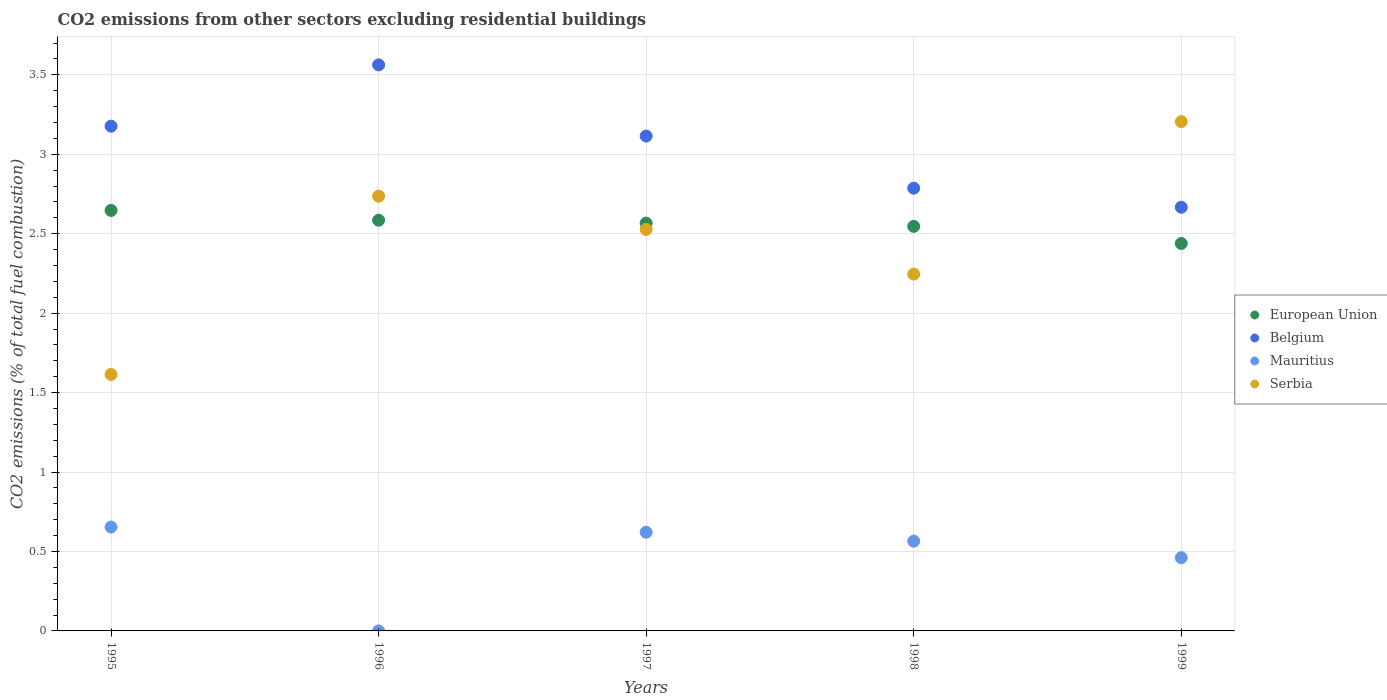How many different coloured dotlines are there?
Ensure brevity in your answer.  4. Is the number of dotlines equal to the number of legend labels?
Offer a very short reply. Yes. What is the total CO2 emitted in Belgium in 1998?
Make the answer very short. 2.79. Across all years, what is the maximum total CO2 emitted in Belgium?
Offer a very short reply. 3.56. Across all years, what is the minimum total CO2 emitted in Serbia?
Give a very brief answer. 1.61. What is the total total CO2 emitted in Mauritius in the graph?
Your answer should be very brief. 2.3. What is the difference between the total CO2 emitted in Serbia in 1997 and that in 1999?
Your answer should be very brief. -0.68. What is the difference between the total CO2 emitted in Belgium in 1995 and the total CO2 emitted in Serbia in 1999?
Provide a short and direct response. -0.03. What is the average total CO2 emitted in Mauritius per year?
Ensure brevity in your answer.  0.46. In the year 1996, what is the difference between the total CO2 emitted in Mauritius and total CO2 emitted in Belgium?
Your answer should be very brief. -3.56. In how many years, is the total CO2 emitted in Belgium greater than 0.6?
Provide a succinct answer. 5. What is the ratio of the total CO2 emitted in Serbia in 1996 to that in 1997?
Ensure brevity in your answer.  1.08. Is the difference between the total CO2 emitted in Mauritius in 1996 and 1999 greater than the difference between the total CO2 emitted in Belgium in 1996 and 1999?
Ensure brevity in your answer.  No. What is the difference between the highest and the second highest total CO2 emitted in Serbia?
Ensure brevity in your answer.  0.47. What is the difference between the highest and the lowest total CO2 emitted in Serbia?
Give a very brief answer. 1.59. In how many years, is the total CO2 emitted in Belgium greater than the average total CO2 emitted in Belgium taken over all years?
Provide a succinct answer. 3. Is it the case that in every year, the sum of the total CO2 emitted in Serbia and total CO2 emitted in Belgium  is greater than the total CO2 emitted in European Union?
Your answer should be compact. Yes. Does the total CO2 emitted in Belgium monotonically increase over the years?
Your answer should be compact. No. How many years are there in the graph?
Offer a very short reply. 5. Does the graph contain any zero values?
Ensure brevity in your answer.  No. Does the graph contain grids?
Keep it short and to the point. Yes. How many legend labels are there?
Keep it short and to the point. 4. How are the legend labels stacked?
Offer a terse response. Vertical. What is the title of the graph?
Ensure brevity in your answer.  CO2 emissions from other sectors excluding residential buildings. What is the label or title of the Y-axis?
Offer a very short reply. CO2 emissions (% of total fuel combustion). What is the CO2 emissions (% of total fuel combustion) in European Union in 1995?
Your response must be concise. 2.65. What is the CO2 emissions (% of total fuel combustion) in Belgium in 1995?
Ensure brevity in your answer.  3.18. What is the CO2 emissions (% of total fuel combustion) in Mauritius in 1995?
Your answer should be very brief. 0.65. What is the CO2 emissions (% of total fuel combustion) of Serbia in 1995?
Offer a very short reply. 1.61. What is the CO2 emissions (% of total fuel combustion) of European Union in 1996?
Your answer should be very brief. 2.58. What is the CO2 emissions (% of total fuel combustion) in Belgium in 1996?
Offer a terse response. 3.56. What is the CO2 emissions (% of total fuel combustion) in Mauritius in 1996?
Offer a terse response. 5.421010862427518e-16. What is the CO2 emissions (% of total fuel combustion) in Serbia in 1996?
Give a very brief answer. 2.74. What is the CO2 emissions (% of total fuel combustion) of European Union in 1997?
Make the answer very short. 2.57. What is the CO2 emissions (% of total fuel combustion) of Belgium in 1997?
Give a very brief answer. 3.11. What is the CO2 emissions (% of total fuel combustion) in Mauritius in 1997?
Your answer should be compact. 0.62. What is the CO2 emissions (% of total fuel combustion) of Serbia in 1997?
Your answer should be compact. 2.53. What is the CO2 emissions (% of total fuel combustion) of European Union in 1998?
Offer a terse response. 2.55. What is the CO2 emissions (% of total fuel combustion) in Belgium in 1998?
Your response must be concise. 2.79. What is the CO2 emissions (% of total fuel combustion) in Mauritius in 1998?
Give a very brief answer. 0.56. What is the CO2 emissions (% of total fuel combustion) of Serbia in 1998?
Your answer should be compact. 2.25. What is the CO2 emissions (% of total fuel combustion) of European Union in 1999?
Your response must be concise. 2.44. What is the CO2 emissions (% of total fuel combustion) in Belgium in 1999?
Keep it short and to the point. 2.67. What is the CO2 emissions (% of total fuel combustion) of Mauritius in 1999?
Keep it short and to the point. 0.46. What is the CO2 emissions (% of total fuel combustion) in Serbia in 1999?
Provide a succinct answer. 3.21. Across all years, what is the maximum CO2 emissions (% of total fuel combustion) of European Union?
Provide a succinct answer. 2.65. Across all years, what is the maximum CO2 emissions (% of total fuel combustion) of Belgium?
Give a very brief answer. 3.56. Across all years, what is the maximum CO2 emissions (% of total fuel combustion) in Mauritius?
Your response must be concise. 0.65. Across all years, what is the maximum CO2 emissions (% of total fuel combustion) in Serbia?
Keep it short and to the point. 3.21. Across all years, what is the minimum CO2 emissions (% of total fuel combustion) of European Union?
Your response must be concise. 2.44. Across all years, what is the minimum CO2 emissions (% of total fuel combustion) in Belgium?
Provide a succinct answer. 2.67. Across all years, what is the minimum CO2 emissions (% of total fuel combustion) of Mauritius?
Keep it short and to the point. 5.421010862427518e-16. Across all years, what is the minimum CO2 emissions (% of total fuel combustion) of Serbia?
Make the answer very short. 1.61. What is the total CO2 emissions (% of total fuel combustion) in European Union in the graph?
Ensure brevity in your answer.  12.78. What is the total CO2 emissions (% of total fuel combustion) in Belgium in the graph?
Keep it short and to the point. 15.31. What is the total CO2 emissions (% of total fuel combustion) in Mauritius in the graph?
Keep it short and to the point. 2.3. What is the total CO2 emissions (% of total fuel combustion) in Serbia in the graph?
Offer a terse response. 12.33. What is the difference between the CO2 emissions (% of total fuel combustion) of European Union in 1995 and that in 1996?
Make the answer very short. 0.06. What is the difference between the CO2 emissions (% of total fuel combustion) of Belgium in 1995 and that in 1996?
Ensure brevity in your answer.  -0.39. What is the difference between the CO2 emissions (% of total fuel combustion) in Mauritius in 1995 and that in 1996?
Offer a very short reply. 0.65. What is the difference between the CO2 emissions (% of total fuel combustion) in Serbia in 1995 and that in 1996?
Provide a short and direct response. -1.12. What is the difference between the CO2 emissions (% of total fuel combustion) in European Union in 1995 and that in 1997?
Offer a very short reply. 0.08. What is the difference between the CO2 emissions (% of total fuel combustion) in Belgium in 1995 and that in 1997?
Offer a terse response. 0.06. What is the difference between the CO2 emissions (% of total fuel combustion) of Mauritius in 1995 and that in 1997?
Your answer should be very brief. 0.03. What is the difference between the CO2 emissions (% of total fuel combustion) of Serbia in 1995 and that in 1997?
Your response must be concise. -0.91. What is the difference between the CO2 emissions (% of total fuel combustion) of European Union in 1995 and that in 1998?
Give a very brief answer. 0.1. What is the difference between the CO2 emissions (% of total fuel combustion) of Belgium in 1995 and that in 1998?
Provide a succinct answer. 0.39. What is the difference between the CO2 emissions (% of total fuel combustion) of Mauritius in 1995 and that in 1998?
Offer a terse response. 0.09. What is the difference between the CO2 emissions (% of total fuel combustion) of Serbia in 1995 and that in 1998?
Offer a very short reply. -0.63. What is the difference between the CO2 emissions (% of total fuel combustion) of European Union in 1995 and that in 1999?
Provide a short and direct response. 0.21. What is the difference between the CO2 emissions (% of total fuel combustion) in Belgium in 1995 and that in 1999?
Your answer should be very brief. 0.51. What is the difference between the CO2 emissions (% of total fuel combustion) in Mauritius in 1995 and that in 1999?
Make the answer very short. 0.19. What is the difference between the CO2 emissions (% of total fuel combustion) in Serbia in 1995 and that in 1999?
Offer a very short reply. -1.59. What is the difference between the CO2 emissions (% of total fuel combustion) of European Union in 1996 and that in 1997?
Keep it short and to the point. 0.02. What is the difference between the CO2 emissions (% of total fuel combustion) in Belgium in 1996 and that in 1997?
Keep it short and to the point. 0.45. What is the difference between the CO2 emissions (% of total fuel combustion) in Mauritius in 1996 and that in 1997?
Your response must be concise. -0.62. What is the difference between the CO2 emissions (% of total fuel combustion) of Serbia in 1996 and that in 1997?
Your answer should be very brief. 0.21. What is the difference between the CO2 emissions (% of total fuel combustion) of European Union in 1996 and that in 1998?
Ensure brevity in your answer.  0.04. What is the difference between the CO2 emissions (% of total fuel combustion) of Belgium in 1996 and that in 1998?
Keep it short and to the point. 0.78. What is the difference between the CO2 emissions (% of total fuel combustion) in Mauritius in 1996 and that in 1998?
Provide a succinct answer. -0.56. What is the difference between the CO2 emissions (% of total fuel combustion) of Serbia in 1996 and that in 1998?
Provide a succinct answer. 0.49. What is the difference between the CO2 emissions (% of total fuel combustion) in European Union in 1996 and that in 1999?
Provide a short and direct response. 0.15. What is the difference between the CO2 emissions (% of total fuel combustion) of Belgium in 1996 and that in 1999?
Offer a very short reply. 0.9. What is the difference between the CO2 emissions (% of total fuel combustion) of Mauritius in 1996 and that in 1999?
Provide a succinct answer. -0.46. What is the difference between the CO2 emissions (% of total fuel combustion) of Serbia in 1996 and that in 1999?
Offer a very short reply. -0.47. What is the difference between the CO2 emissions (% of total fuel combustion) of European Union in 1997 and that in 1998?
Keep it short and to the point. 0.02. What is the difference between the CO2 emissions (% of total fuel combustion) of Belgium in 1997 and that in 1998?
Your answer should be very brief. 0.33. What is the difference between the CO2 emissions (% of total fuel combustion) of Mauritius in 1997 and that in 1998?
Keep it short and to the point. 0.06. What is the difference between the CO2 emissions (% of total fuel combustion) in Serbia in 1997 and that in 1998?
Provide a succinct answer. 0.28. What is the difference between the CO2 emissions (% of total fuel combustion) of European Union in 1997 and that in 1999?
Provide a short and direct response. 0.13. What is the difference between the CO2 emissions (% of total fuel combustion) in Belgium in 1997 and that in 1999?
Make the answer very short. 0.45. What is the difference between the CO2 emissions (% of total fuel combustion) in Mauritius in 1997 and that in 1999?
Give a very brief answer. 0.16. What is the difference between the CO2 emissions (% of total fuel combustion) of Serbia in 1997 and that in 1999?
Offer a terse response. -0.68. What is the difference between the CO2 emissions (% of total fuel combustion) in European Union in 1998 and that in 1999?
Your answer should be compact. 0.11. What is the difference between the CO2 emissions (% of total fuel combustion) in Belgium in 1998 and that in 1999?
Ensure brevity in your answer.  0.12. What is the difference between the CO2 emissions (% of total fuel combustion) of Mauritius in 1998 and that in 1999?
Make the answer very short. 0.1. What is the difference between the CO2 emissions (% of total fuel combustion) of Serbia in 1998 and that in 1999?
Make the answer very short. -0.96. What is the difference between the CO2 emissions (% of total fuel combustion) in European Union in 1995 and the CO2 emissions (% of total fuel combustion) in Belgium in 1996?
Make the answer very short. -0.92. What is the difference between the CO2 emissions (% of total fuel combustion) of European Union in 1995 and the CO2 emissions (% of total fuel combustion) of Mauritius in 1996?
Offer a terse response. 2.65. What is the difference between the CO2 emissions (% of total fuel combustion) of European Union in 1995 and the CO2 emissions (% of total fuel combustion) of Serbia in 1996?
Your response must be concise. -0.09. What is the difference between the CO2 emissions (% of total fuel combustion) of Belgium in 1995 and the CO2 emissions (% of total fuel combustion) of Mauritius in 1996?
Your response must be concise. 3.18. What is the difference between the CO2 emissions (% of total fuel combustion) in Belgium in 1995 and the CO2 emissions (% of total fuel combustion) in Serbia in 1996?
Offer a terse response. 0.44. What is the difference between the CO2 emissions (% of total fuel combustion) of Mauritius in 1995 and the CO2 emissions (% of total fuel combustion) of Serbia in 1996?
Give a very brief answer. -2.08. What is the difference between the CO2 emissions (% of total fuel combustion) of European Union in 1995 and the CO2 emissions (% of total fuel combustion) of Belgium in 1997?
Make the answer very short. -0.47. What is the difference between the CO2 emissions (% of total fuel combustion) of European Union in 1995 and the CO2 emissions (% of total fuel combustion) of Mauritius in 1997?
Your answer should be very brief. 2.03. What is the difference between the CO2 emissions (% of total fuel combustion) of European Union in 1995 and the CO2 emissions (% of total fuel combustion) of Serbia in 1997?
Provide a succinct answer. 0.12. What is the difference between the CO2 emissions (% of total fuel combustion) of Belgium in 1995 and the CO2 emissions (% of total fuel combustion) of Mauritius in 1997?
Your response must be concise. 2.56. What is the difference between the CO2 emissions (% of total fuel combustion) of Belgium in 1995 and the CO2 emissions (% of total fuel combustion) of Serbia in 1997?
Make the answer very short. 0.65. What is the difference between the CO2 emissions (% of total fuel combustion) in Mauritius in 1995 and the CO2 emissions (% of total fuel combustion) in Serbia in 1997?
Your response must be concise. -1.87. What is the difference between the CO2 emissions (% of total fuel combustion) of European Union in 1995 and the CO2 emissions (% of total fuel combustion) of Belgium in 1998?
Your answer should be compact. -0.14. What is the difference between the CO2 emissions (% of total fuel combustion) in European Union in 1995 and the CO2 emissions (% of total fuel combustion) in Mauritius in 1998?
Your response must be concise. 2.08. What is the difference between the CO2 emissions (% of total fuel combustion) of European Union in 1995 and the CO2 emissions (% of total fuel combustion) of Serbia in 1998?
Provide a short and direct response. 0.4. What is the difference between the CO2 emissions (% of total fuel combustion) in Belgium in 1995 and the CO2 emissions (% of total fuel combustion) in Mauritius in 1998?
Offer a terse response. 2.61. What is the difference between the CO2 emissions (% of total fuel combustion) in Mauritius in 1995 and the CO2 emissions (% of total fuel combustion) in Serbia in 1998?
Make the answer very short. -1.59. What is the difference between the CO2 emissions (% of total fuel combustion) in European Union in 1995 and the CO2 emissions (% of total fuel combustion) in Belgium in 1999?
Ensure brevity in your answer.  -0.02. What is the difference between the CO2 emissions (% of total fuel combustion) of European Union in 1995 and the CO2 emissions (% of total fuel combustion) of Mauritius in 1999?
Provide a succinct answer. 2.19. What is the difference between the CO2 emissions (% of total fuel combustion) of European Union in 1995 and the CO2 emissions (% of total fuel combustion) of Serbia in 1999?
Your answer should be very brief. -0.56. What is the difference between the CO2 emissions (% of total fuel combustion) of Belgium in 1995 and the CO2 emissions (% of total fuel combustion) of Mauritius in 1999?
Ensure brevity in your answer.  2.72. What is the difference between the CO2 emissions (% of total fuel combustion) of Belgium in 1995 and the CO2 emissions (% of total fuel combustion) of Serbia in 1999?
Your answer should be compact. -0.03. What is the difference between the CO2 emissions (% of total fuel combustion) of Mauritius in 1995 and the CO2 emissions (% of total fuel combustion) of Serbia in 1999?
Offer a very short reply. -2.55. What is the difference between the CO2 emissions (% of total fuel combustion) of European Union in 1996 and the CO2 emissions (% of total fuel combustion) of Belgium in 1997?
Give a very brief answer. -0.53. What is the difference between the CO2 emissions (% of total fuel combustion) of European Union in 1996 and the CO2 emissions (% of total fuel combustion) of Mauritius in 1997?
Provide a short and direct response. 1.96. What is the difference between the CO2 emissions (% of total fuel combustion) of European Union in 1996 and the CO2 emissions (% of total fuel combustion) of Serbia in 1997?
Provide a succinct answer. 0.06. What is the difference between the CO2 emissions (% of total fuel combustion) of Belgium in 1996 and the CO2 emissions (% of total fuel combustion) of Mauritius in 1997?
Make the answer very short. 2.94. What is the difference between the CO2 emissions (% of total fuel combustion) of Belgium in 1996 and the CO2 emissions (% of total fuel combustion) of Serbia in 1997?
Your answer should be compact. 1.04. What is the difference between the CO2 emissions (% of total fuel combustion) in Mauritius in 1996 and the CO2 emissions (% of total fuel combustion) in Serbia in 1997?
Provide a succinct answer. -2.53. What is the difference between the CO2 emissions (% of total fuel combustion) in European Union in 1996 and the CO2 emissions (% of total fuel combustion) in Belgium in 1998?
Your answer should be compact. -0.2. What is the difference between the CO2 emissions (% of total fuel combustion) of European Union in 1996 and the CO2 emissions (% of total fuel combustion) of Mauritius in 1998?
Your response must be concise. 2.02. What is the difference between the CO2 emissions (% of total fuel combustion) of European Union in 1996 and the CO2 emissions (% of total fuel combustion) of Serbia in 1998?
Ensure brevity in your answer.  0.34. What is the difference between the CO2 emissions (% of total fuel combustion) in Belgium in 1996 and the CO2 emissions (% of total fuel combustion) in Mauritius in 1998?
Provide a succinct answer. 3. What is the difference between the CO2 emissions (% of total fuel combustion) in Belgium in 1996 and the CO2 emissions (% of total fuel combustion) in Serbia in 1998?
Your answer should be very brief. 1.32. What is the difference between the CO2 emissions (% of total fuel combustion) of Mauritius in 1996 and the CO2 emissions (% of total fuel combustion) of Serbia in 1998?
Keep it short and to the point. -2.25. What is the difference between the CO2 emissions (% of total fuel combustion) in European Union in 1996 and the CO2 emissions (% of total fuel combustion) in Belgium in 1999?
Provide a succinct answer. -0.08. What is the difference between the CO2 emissions (% of total fuel combustion) in European Union in 1996 and the CO2 emissions (% of total fuel combustion) in Mauritius in 1999?
Give a very brief answer. 2.12. What is the difference between the CO2 emissions (% of total fuel combustion) of European Union in 1996 and the CO2 emissions (% of total fuel combustion) of Serbia in 1999?
Keep it short and to the point. -0.62. What is the difference between the CO2 emissions (% of total fuel combustion) in Belgium in 1996 and the CO2 emissions (% of total fuel combustion) in Mauritius in 1999?
Keep it short and to the point. 3.1. What is the difference between the CO2 emissions (% of total fuel combustion) in Belgium in 1996 and the CO2 emissions (% of total fuel combustion) in Serbia in 1999?
Your answer should be very brief. 0.36. What is the difference between the CO2 emissions (% of total fuel combustion) in Mauritius in 1996 and the CO2 emissions (% of total fuel combustion) in Serbia in 1999?
Give a very brief answer. -3.21. What is the difference between the CO2 emissions (% of total fuel combustion) in European Union in 1997 and the CO2 emissions (% of total fuel combustion) in Belgium in 1998?
Your response must be concise. -0.22. What is the difference between the CO2 emissions (% of total fuel combustion) of European Union in 1997 and the CO2 emissions (% of total fuel combustion) of Mauritius in 1998?
Provide a short and direct response. 2. What is the difference between the CO2 emissions (% of total fuel combustion) of European Union in 1997 and the CO2 emissions (% of total fuel combustion) of Serbia in 1998?
Make the answer very short. 0.32. What is the difference between the CO2 emissions (% of total fuel combustion) of Belgium in 1997 and the CO2 emissions (% of total fuel combustion) of Mauritius in 1998?
Your answer should be compact. 2.55. What is the difference between the CO2 emissions (% of total fuel combustion) in Belgium in 1997 and the CO2 emissions (% of total fuel combustion) in Serbia in 1998?
Provide a short and direct response. 0.87. What is the difference between the CO2 emissions (% of total fuel combustion) in Mauritius in 1997 and the CO2 emissions (% of total fuel combustion) in Serbia in 1998?
Provide a succinct answer. -1.62. What is the difference between the CO2 emissions (% of total fuel combustion) in European Union in 1997 and the CO2 emissions (% of total fuel combustion) in Belgium in 1999?
Provide a short and direct response. -0.1. What is the difference between the CO2 emissions (% of total fuel combustion) of European Union in 1997 and the CO2 emissions (% of total fuel combustion) of Mauritius in 1999?
Your answer should be compact. 2.11. What is the difference between the CO2 emissions (% of total fuel combustion) in European Union in 1997 and the CO2 emissions (% of total fuel combustion) in Serbia in 1999?
Ensure brevity in your answer.  -0.64. What is the difference between the CO2 emissions (% of total fuel combustion) in Belgium in 1997 and the CO2 emissions (% of total fuel combustion) in Mauritius in 1999?
Give a very brief answer. 2.65. What is the difference between the CO2 emissions (% of total fuel combustion) in Belgium in 1997 and the CO2 emissions (% of total fuel combustion) in Serbia in 1999?
Make the answer very short. -0.09. What is the difference between the CO2 emissions (% of total fuel combustion) of Mauritius in 1997 and the CO2 emissions (% of total fuel combustion) of Serbia in 1999?
Your answer should be compact. -2.58. What is the difference between the CO2 emissions (% of total fuel combustion) in European Union in 1998 and the CO2 emissions (% of total fuel combustion) in Belgium in 1999?
Give a very brief answer. -0.12. What is the difference between the CO2 emissions (% of total fuel combustion) in European Union in 1998 and the CO2 emissions (% of total fuel combustion) in Mauritius in 1999?
Provide a succinct answer. 2.09. What is the difference between the CO2 emissions (% of total fuel combustion) of European Union in 1998 and the CO2 emissions (% of total fuel combustion) of Serbia in 1999?
Make the answer very short. -0.66. What is the difference between the CO2 emissions (% of total fuel combustion) in Belgium in 1998 and the CO2 emissions (% of total fuel combustion) in Mauritius in 1999?
Give a very brief answer. 2.33. What is the difference between the CO2 emissions (% of total fuel combustion) of Belgium in 1998 and the CO2 emissions (% of total fuel combustion) of Serbia in 1999?
Provide a short and direct response. -0.42. What is the difference between the CO2 emissions (% of total fuel combustion) in Mauritius in 1998 and the CO2 emissions (% of total fuel combustion) in Serbia in 1999?
Ensure brevity in your answer.  -2.64. What is the average CO2 emissions (% of total fuel combustion) of European Union per year?
Keep it short and to the point. 2.56. What is the average CO2 emissions (% of total fuel combustion) of Belgium per year?
Offer a terse response. 3.06. What is the average CO2 emissions (% of total fuel combustion) of Mauritius per year?
Your answer should be very brief. 0.46. What is the average CO2 emissions (% of total fuel combustion) of Serbia per year?
Offer a terse response. 2.47. In the year 1995, what is the difference between the CO2 emissions (% of total fuel combustion) in European Union and CO2 emissions (% of total fuel combustion) in Belgium?
Your response must be concise. -0.53. In the year 1995, what is the difference between the CO2 emissions (% of total fuel combustion) in European Union and CO2 emissions (% of total fuel combustion) in Mauritius?
Give a very brief answer. 1.99. In the year 1995, what is the difference between the CO2 emissions (% of total fuel combustion) of European Union and CO2 emissions (% of total fuel combustion) of Serbia?
Offer a very short reply. 1.03. In the year 1995, what is the difference between the CO2 emissions (% of total fuel combustion) of Belgium and CO2 emissions (% of total fuel combustion) of Mauritius?
Your response must be concise. 2.52. In the year 1995, what is the difference between the CO2 emissions (% of total fuel combustion) in Belgium and CO2 emissions (% of total fuel combustion) in Serbia?
Your response must be concise. 1.56. In the year 1995, what is the difference between the CO2 emissions (% of total fuel combustion) in Mauritius and CO2 emissions (% of total fuel combustion) in Serbia?
Provide a short and direct response. -0.96. In the year 1996, what is the difference between the CO2 emissions (% of total fuel combustion) in European Union and CO2 emissions (% of total fuel combustion) in Belgium?
Your response must be concise. -0.98. In the year 1996, what is the difference between the CO2 emissions (% of total fuel combustion) in European Union and CO2 emissions (% of total fuel combustion) in Mauritius?
Provide a short and direct response. 2.58. In the year 1996, what is the difference between the CO2 emissions (% of total fuel combustion) of European Union and CO2 emissions (% of total fuel combustion) of Serbia?
Your response must be concise. -0.15. In the year 1996, what is the difference between the CO2 emissions (% of total fuel combustion) in Belgium and CO2 emissions (% of total fuel combustion) in Mauritius?
Your answer should be very brief. 3.56. In the year 1996, what is the difference between the CO2 emissions (% of total fuel combustion) of Belgium and CO2 emissions (% of total fuel combustion) of Serbia?
Provide a short and direct response. 0.83. In the year 1996, what is the difference between the CO2 emissions (% of total fuel combustion) of Mauritius and CO2 emissions (% of total fuel combustion) of Serbia?
Your answer should be compact. -2.74. In the year 1997, what is the difference between the CO2 emissions (% of total fuel combustion) of European Union and CO2 emissions (% of total fuel combustion) of Belgium?
Provide a short and direct response. -0.55. In the year 1997, what is the difference between the CO2 emissions (% of total fuel combustion) of European Union and CO2 emissions (% of total fuel combustion) of Mauritius?
Your response must be concise. 1.95. In the year 1997, what is the difference between the CO2 emissions (% of total fuel combustion) in European Union and CO2 emissions (% of total fuel combustion) in Serbia?
Provide a succinct answer. 0.04. In the year 1997, what is the difference between the CO2 emissions (% of total fuel combustion) of Belgium and CO2 emissions (% of total fuel combustion) of Mauritius?
Your response must be concise. 2.49. In the year 1997, what is the difference between the CO2 emissions (% of total fuel combustion) of Belgium and CO2 emissions (% of total fuel combustion) of Serbia?
Offer a terse response. 0.59. In the year 1997, what is the difference between the CO2 emissions (% of total fuel combustion) of Mauritius and CO2 emissions (% of total fuel combustion) of Serbia?
Your answer should be compact. -1.91. In the year 1998, what is the difference between the CO2 emissions (% of total fuel combustion) in European Union and CO2 emissions (% of total fuel combustion) in Belgium?
Ensure brevity in your answer.  -0.24. In the year 1998, what is the difference between the CO2 emissions (% of total fuel combustion) of European Union and CO2 emissions (% of total fuel combustion) of Mauritius?
Your response must be concise. 1.98. In the year 1998, what is the difference between the CO2 emissions (% of total fuel combustion) in European Union and CO2 emissions (% of total fuel combustion) in Serbia?
Give a very brief answer. 0.3. In the year 1998, what is the difference between the CO2 emissions (% of total fuel combustion) in Belgium and CO2 emissions (% of total fuel combustion) in Mauritius?
Make the answer very short. 2.22. In the year 1998, what is the difference between the CO2 emissions (% of total fuel combustion) of Belgium and CO2 emissions (% of total fuel combustion) of Serbia?
Provide a succinct answer. 0.54. In the year 1998, what is the difference between the CO2 emissions (% of total fuel combustion) of Mauritius and CO2 emissions (% of total fuel combustion) of Serbia?
Provide a short and direct response. -1.68. In the year 1999, what is the difference between the CO2 emissions (% of total fuel combustion) in European Union and CO2 emissions (% of total fuel combustion) in Belgium?
Ensure brevity in your answer.  -0.23. In the year 1999, what is the difference between the CO2 emissions (% of total fuel combustion) of European Union and CO2 emissions (% of total fuel combustion) of Mauritius?
Make the answer very short. 1.98. In the year 1999, what is the difference between the CO2 emissions (% of total fuel combustion) of European Union and CO2 emissions (% of total fuel combustion) of Serbia?
Provide a short and direct response. -0.77. In the year 1999, what is the difference between the CO2 emissions (% of total fuel combustion) of Belgium and CO2 emissions (% of total fuel combustion) of Mauritius?
Your answer should be compact. 2.21. In the year 1999, what is the difference between the CO2 emissions (% of total fuel combustion) in Belgium and CO2 emissions (% of total fuel combustion) in Serbia?
Ensure brevity in your answer.  -0.54. In the year 1999, what is the difference between the CO2 emissions (% of total fuel combustion) of Mauritius and CO2 emissions (% of total fuel combustion) of Serbia?
Offer a very short reply. -2.74. What is the ratio of the CO2 emissions (% of total fuel combustion) in European Union in 1995 to that in 1996?
Your answer should be very brief. 1.02. What is the ratio of the CO2 emissions (% of total fuel combustion) in Belgium in 1995 to that in 1996?
Your answer should be very brief. 0.89. What is the ratio of the CO2 emissions (% of total fuel combustion) of Mauritius in 1995 to that in 1996?
Provide a short and direct response. 1.21e+15. What is the ratio of the CO2 emissions (% of total fuel combustion) in Serbia in 1995 to that in 1996?
Make the answer very short. 0.59. What is the ratio of the CO2 emissions (% of total fuel combustion) of European Union in 1995 to that in 1997?
Ensure brevity in your answer.  1.03. What is the ratio of the CO2 emissions (% of total fuel combustion) of Mauritius in 1995 to that in 1997?
Keep it short and to the point. 1.05. What is the ratio of the CO2 emissions (% of total fuel combustion) of Serbia in 1995 to that in 1997?
Make the answer very short. 0.64. What is the ratio of the CO2 emissions (% of total fuel combustion) in European Union in 1995 to that in 1998?
Your response must be concise. 1.04. What is the ratio of the CO2 emissions (% of total fuel combustion) in Belgium in 1995 to that in 1998?
Your answer should be very brief. 1.14. What is the ratio of the CO2 emissions (% of total fuel combustion) in Mauritius in 1995 to that in 1998?
Keep it short and to the point. 1.16. What is the ratio of the CO2 emissions (% of total fuel combustion) in Serbia in 1995 to that in 1998?
Offer a terse response. 0.72. What is the ratio of the CO2 emissions (% of total fuel combustion) of European Union in 1995 to that in 1999?
Keep it short and to the point. 1.09. What is the ratio of the CO2 emissions (% of total fuel combustion) of Belgium in 1995 to that in 1999?
Your answer should be very brief. 1.19. What is the ratio of the CO2 emissions (% of total fuel combustion) of Mauritius in 1995 to that in 1999?
Keep it short and to the point. 1.42. What is the ratio of the CO2 emissions (% of total fuel combustion) of Serbia in 1995 to that in 1999?
Offer a very short reply. 0.5. What is the ratio of the CO2 emissions (% of total fuel combustion) in European Union in 1996 to that in 1997?
Your response must be concise. 1.01. What is the ratio of the CO2 emissions (% of total fuel combustion) in Belgium in 1996 to that in 1997?
Provide a succinct answer. 1.14. What is the ratio of the CO2 emissions (% of total fuel combustion) in Mauritius in 1996 to that in 1997?
Offer a very short reply. 0. What is the ratio of the CO2 emissions (% of total fuel combustion) of Serbia in 1996 to that in 1997?
Provide a short and direct response. 1.08. What is the ratio of the CO2 emissions (% of total fuel combustion) in European Union in 1996 to that in 1998?
Provide a succinct answer. 1.02. What is the ratio of the CO2 emissions (% of total fuel combustion) in Belgium in 1996 to that in 1998?
Ensure brevity in your answer.  1.28. What is the ratio of the CO2 emissions (% of total fuel combustion) in Mauritius in 1996 to that in 1998?
Provide a succinct answer. 0. What is the ratio of the CO2 emissions (% of total fuel combustion) in Serbia in 1996 to that in 1998?
Give a very brief answer. 1.22. What is the ratio of the CO2 emissions (% of total fuel combustion) in European Union in 1996 to that in 1999?
Give a very brief answer. 1.06. What is the ratio of the CO2 emissions (% of total fuel combustion) of Belgium in 1996 to that in 1999?
Your response must be concise. 1.34. What is the ratio of the CO2 emissions (% of total fuel combustion) in Serbia in 1996 to that in 1999?
Give a very brief answer. 0.85. What is the ratio of the CO2 emissions (% of total fuel combustion) in European Union in 1997 to that in 1998?
Give a very brief answer. 1.01. What is the ratio of the CO2 emissions (% of total fuel combustion) in Belgium in 1997 to that in 1998?
Your answer should be compact. 1.12. What is the ratio of the CO2 emissions (% of total fuel combustion) of Mauritius in 1997 to that in 1998?
Offer a terse response. 1.1. What is the ratio of the CO2 emissions (% of total fuel combustion) in Serbia in 1997 to that in 1998?
Make the answer very short. 1.13. What is the ratio of the CO2 emissions (% of total fuel combustion) of European Union in 1997 to that in 1999?
Make the answer very short. 1.05. What is the ratio of the CO2 emissions (% of total fuel combustion) in Belgium in 1997 to that in 1999?
Provide a short and direct response. 1.17. What is the ratio of the CO2 emissions (% of total fuel combustion) of Mauritius in 1997 to that in 1999?
Your answer should be very brief. 1.35. What is the ratio of the CO2 emissions (% of total fuel combustion) of Serbia in 1997 to that in 1999?
Provide a short and direct response. 0.79. What is the ratio of the CO2 emissions (% of total fuel combustion) of European Union in 1998 to that in 1999?
Keep it short and to the point. 1.04. What is the ratio of the CO2 emissions (% of total fuel combustion) in Belgium in 1998 to that in 1999?
Make the answer very short. 1.05. What is the ratio of the CO2 emissions (% of total fuel combustion) of Mauritius in 1998 to that in 1999?
Ensure brevity in your answer.  1.23. What is the ratio of the CO2 emissions (% of total fuel combustion) in Serbia in 1998 to that in 1999?
Ensure brevity in your answer.  0.7. What is the difference between the highest and the second highest CO2 emissions (% of total fuel combustion) of European Union?
Your answer should be very brief. 0.06. What is the difference between the highest and the second highest CO2 emissions (% of total fuel combustion) of Belgium?
Provide a short and direct response. 0.39. What is the difference between the highest and the second highest CO2 emissions (% of total fuel combustion) of Mauritius?
Ensure brevity in your answer.  0.03. What is the difference between the highest and the second highest CO2 emissions (% of total fuel combustion) of Serbia?
Make the answer very short. 0.47. What is the difference between the highest and the lowest CO2 emissions (% of total fuel combustion) of European Union?
Offer a very short reply. 0.21. What is the difference between the highest and the lowest CO2 emissions (% of total fuel combustion) of Belgium?
Your answer should be compact. 0.9. What is the difference between the highest and the lowest CO2 emissions (% of total fuel combustion) in Mauritius?
Your response must be concise. 0.65. What is the difference between the highest and the lowest CO2 emissions (% of total fuel combustion) in Serbia?
Provide a short and direct response. 1.59. 